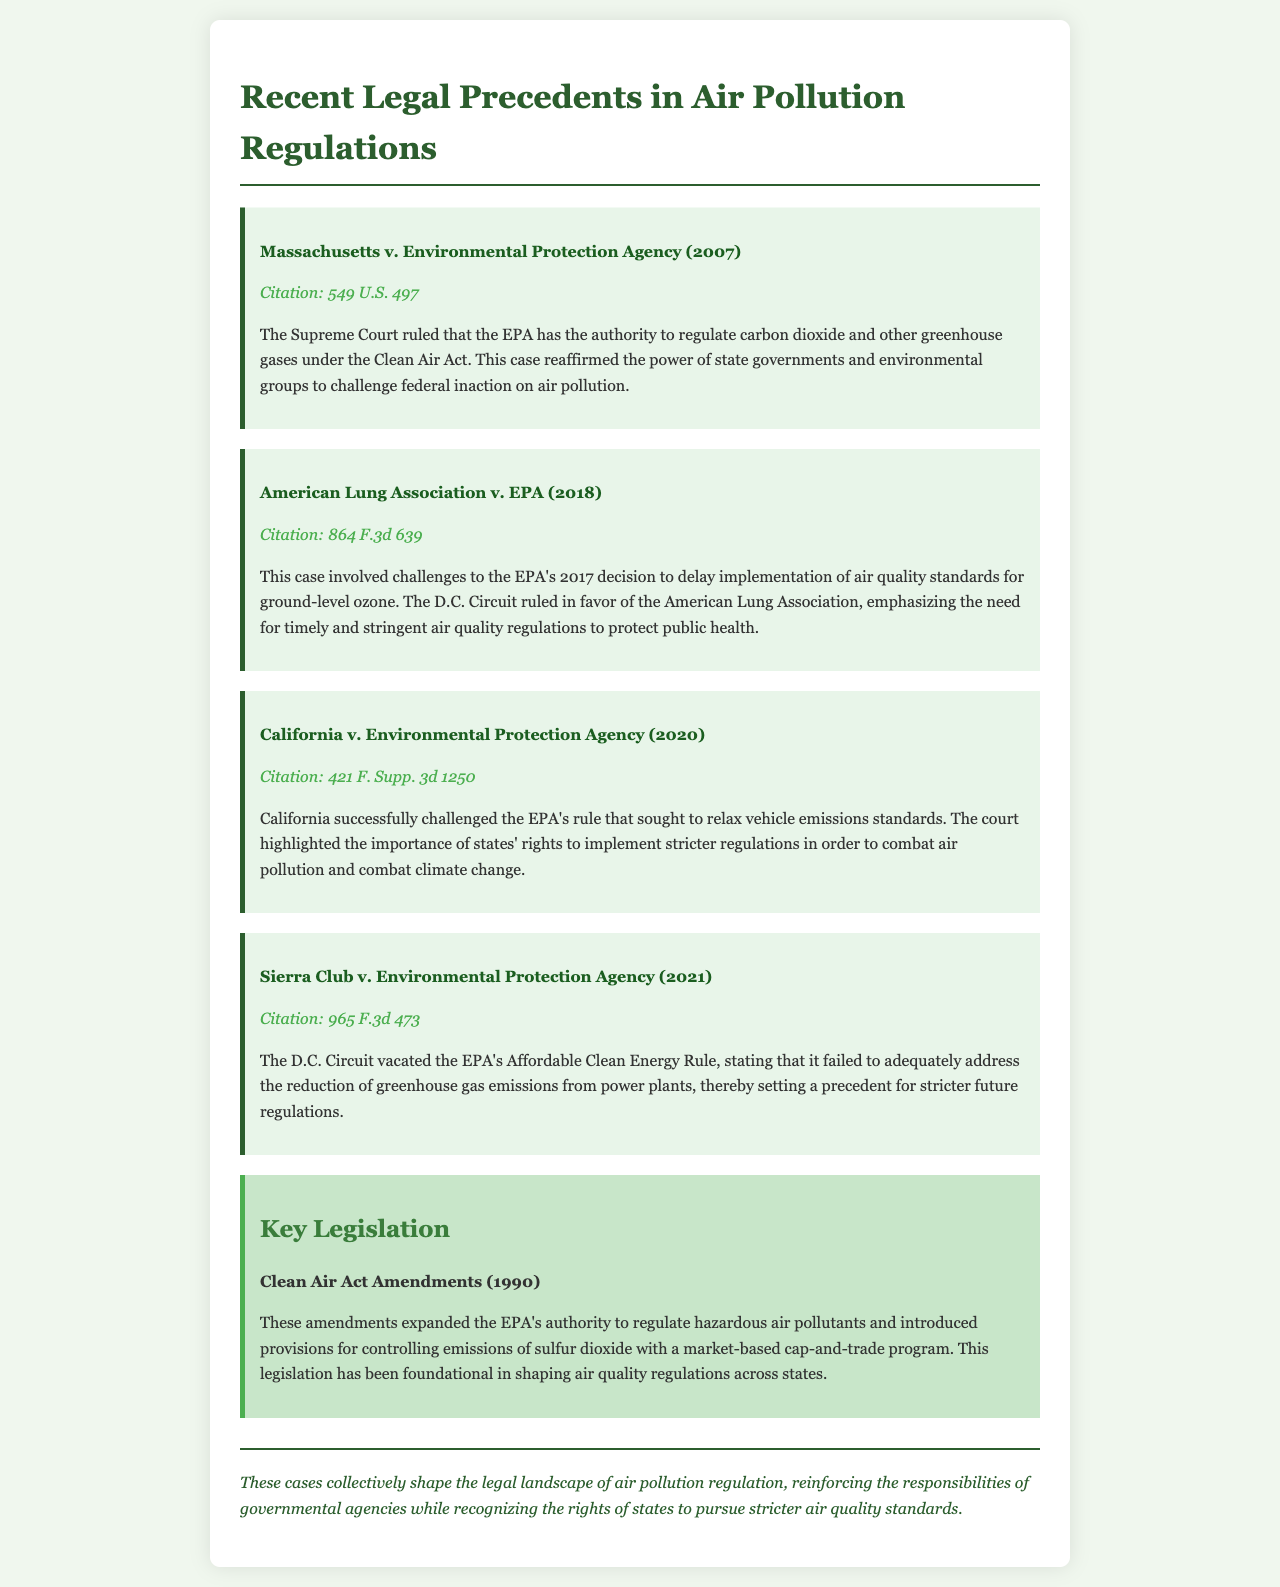What is the title of the document? The title is stated in the header of the document.
Answer: Recent Legal Precedents in Air Pollution Regulations Who wrote the opinion for Massachusetts v. Environmental Protection Agency? This is deduced from the case description highlighting the Supreme Court ruling.
Answer: Supreme Court What year was the Clean Air Act Amendments enacted? The year is specified within the key legislation section of the document.
Answer: 1990 Which organization challenged the EPA's 2017 decision in American Lung Association v. EPA? This is explicitly mentioned in the case description.
Answer: American Lung Association What is the citation for California v. Environmental Protection Agency? The citation is noted below the case title in the document.
Answer: 421 F. Supp. 3d 1250 What significant power did the Supreme Court reaffirm in Massachusetts v. EPA? This is derived from the content explaining the court’s ruling.
Answer: Authority to regulate greenhouse gases What impact did California v. Environmental Protection Agency have on vehicle emissions standards? This is addressed in the case description, which outlines the result of the legal challenge.
Answer: Relaxation of vehicle emissions standards was challenged How did the court rule in Sierra Club v. Environmental Protection Agency? The ruling is detailed in the case description regarding its outcome.
Answer: Vacated the Affordable Clean Energy Rule What main aspect do the cases collectively address regarding air pollution regulation? This is summarized in the conclusion section of the document.
Answer: Responsibilities of governmental agencies 